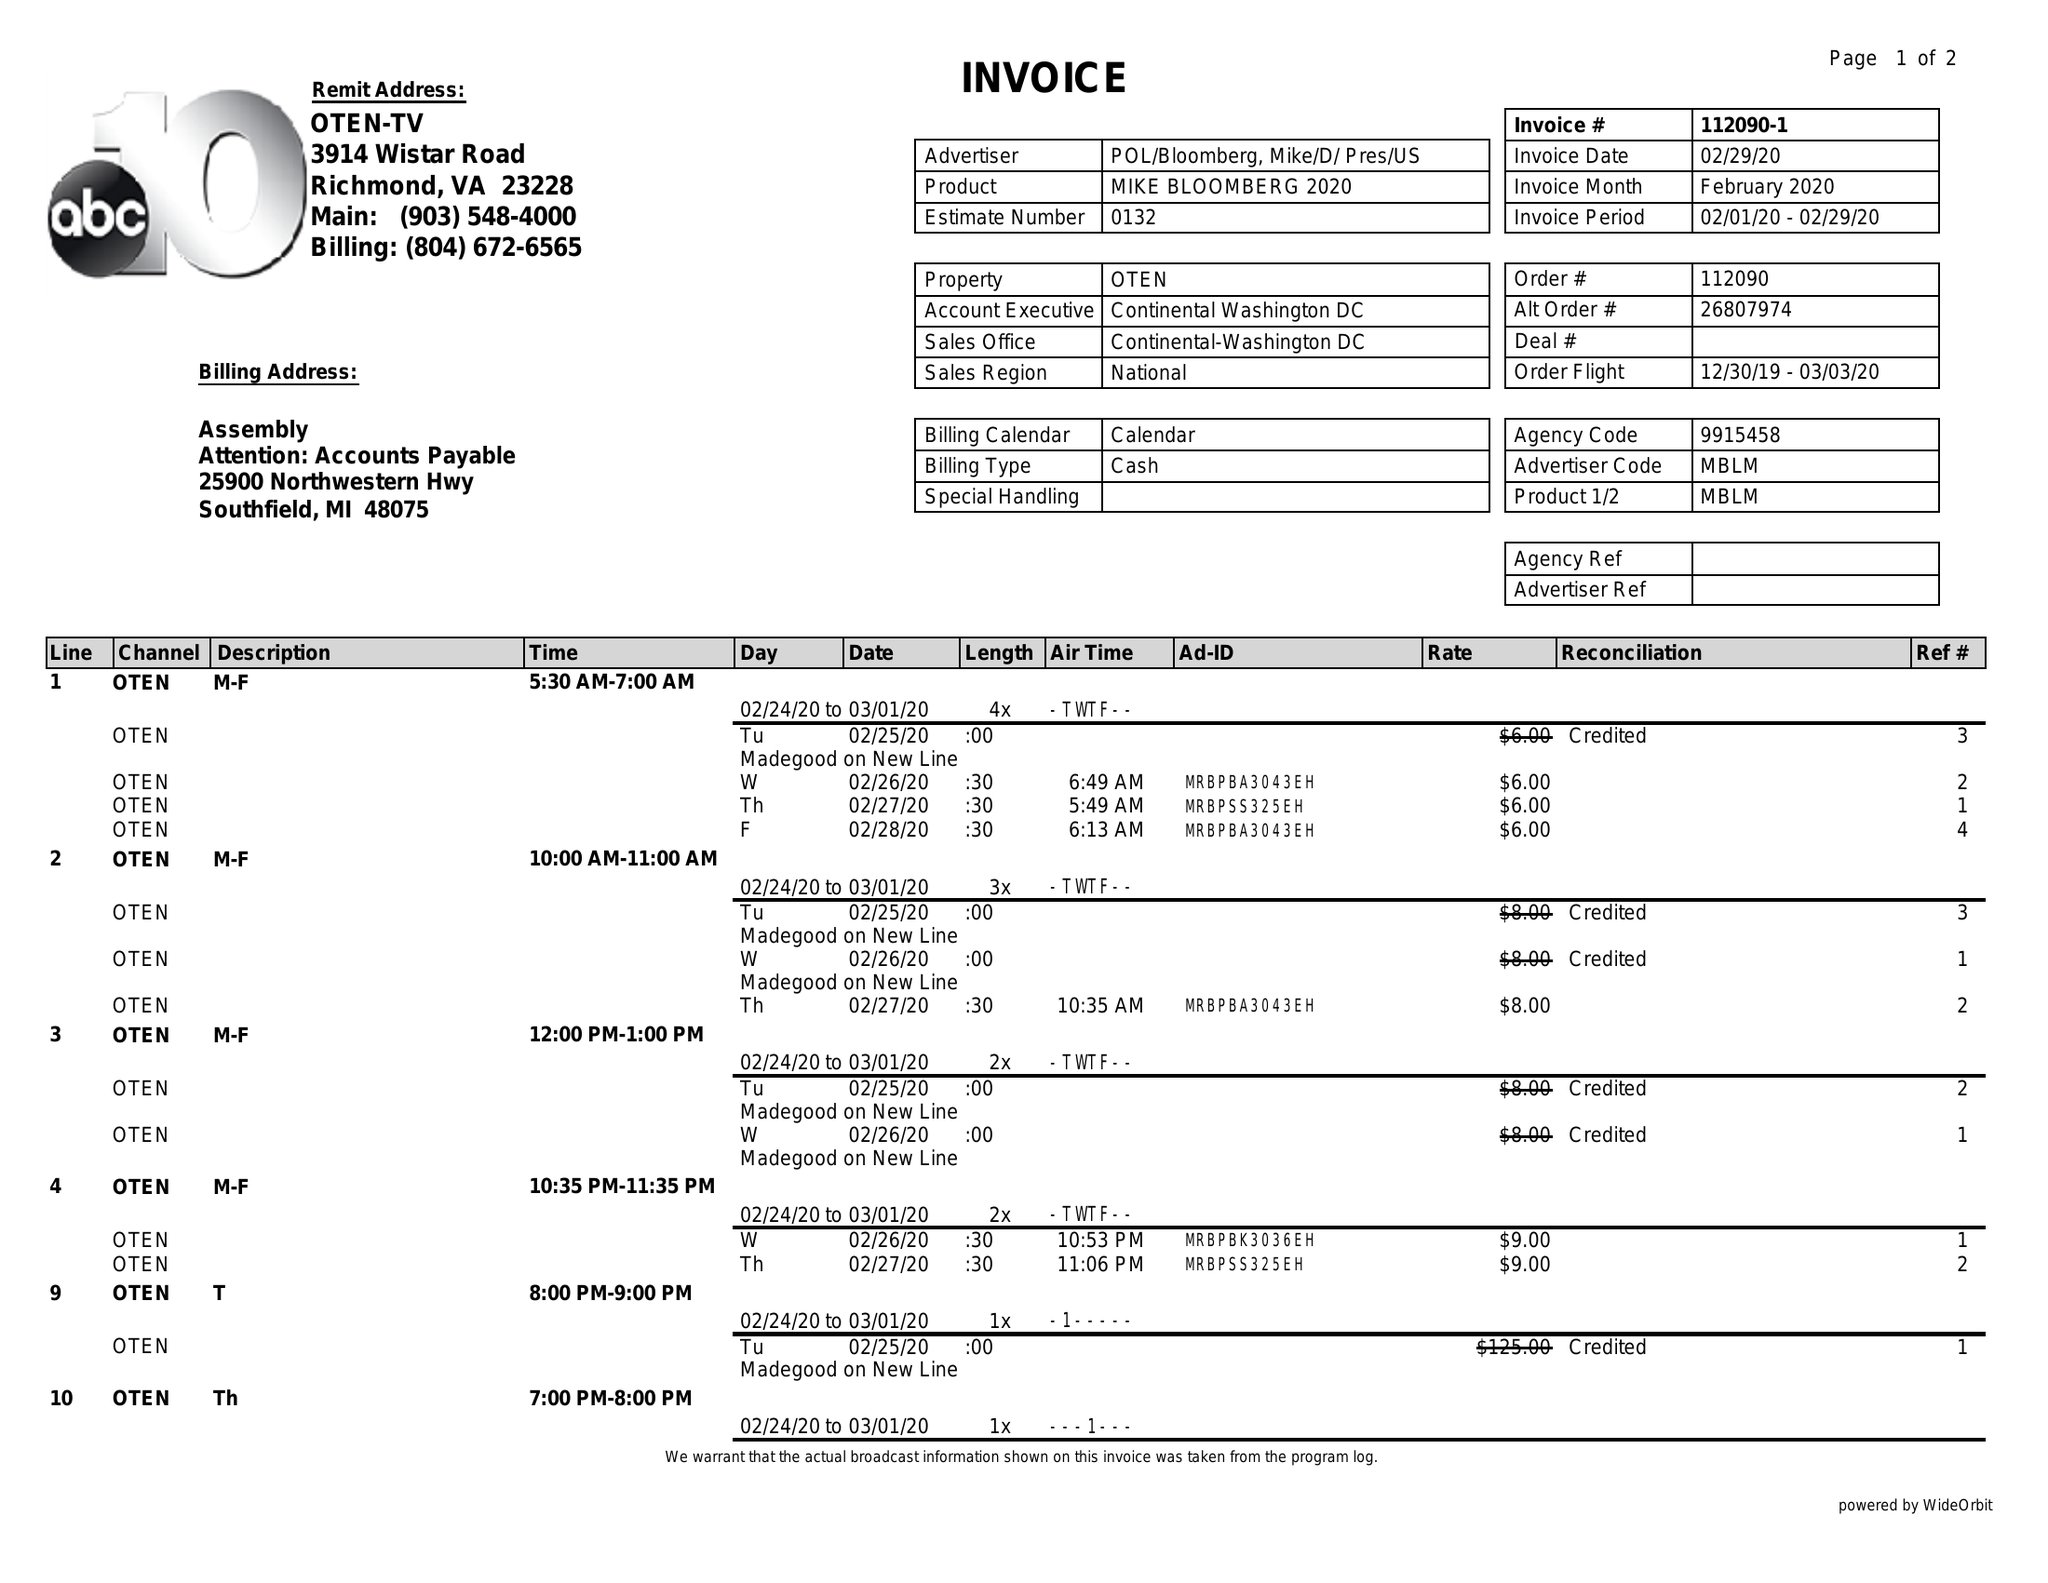What is the value for the flight_from?
Answer the question using a single word or phrase. 12/30/19 